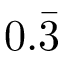<formula> <loc_0><loc_0><loc_500><loc_500>0 . \bar { 3 }</formula> 